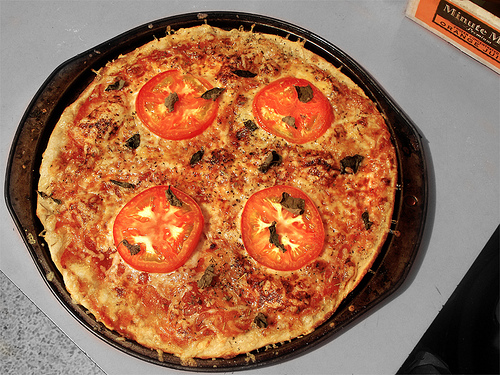<image>
Is there a pizza on the table? Yes. Looking at the image, I can see the pizza is positioned on top of the table, with the table providing support. 